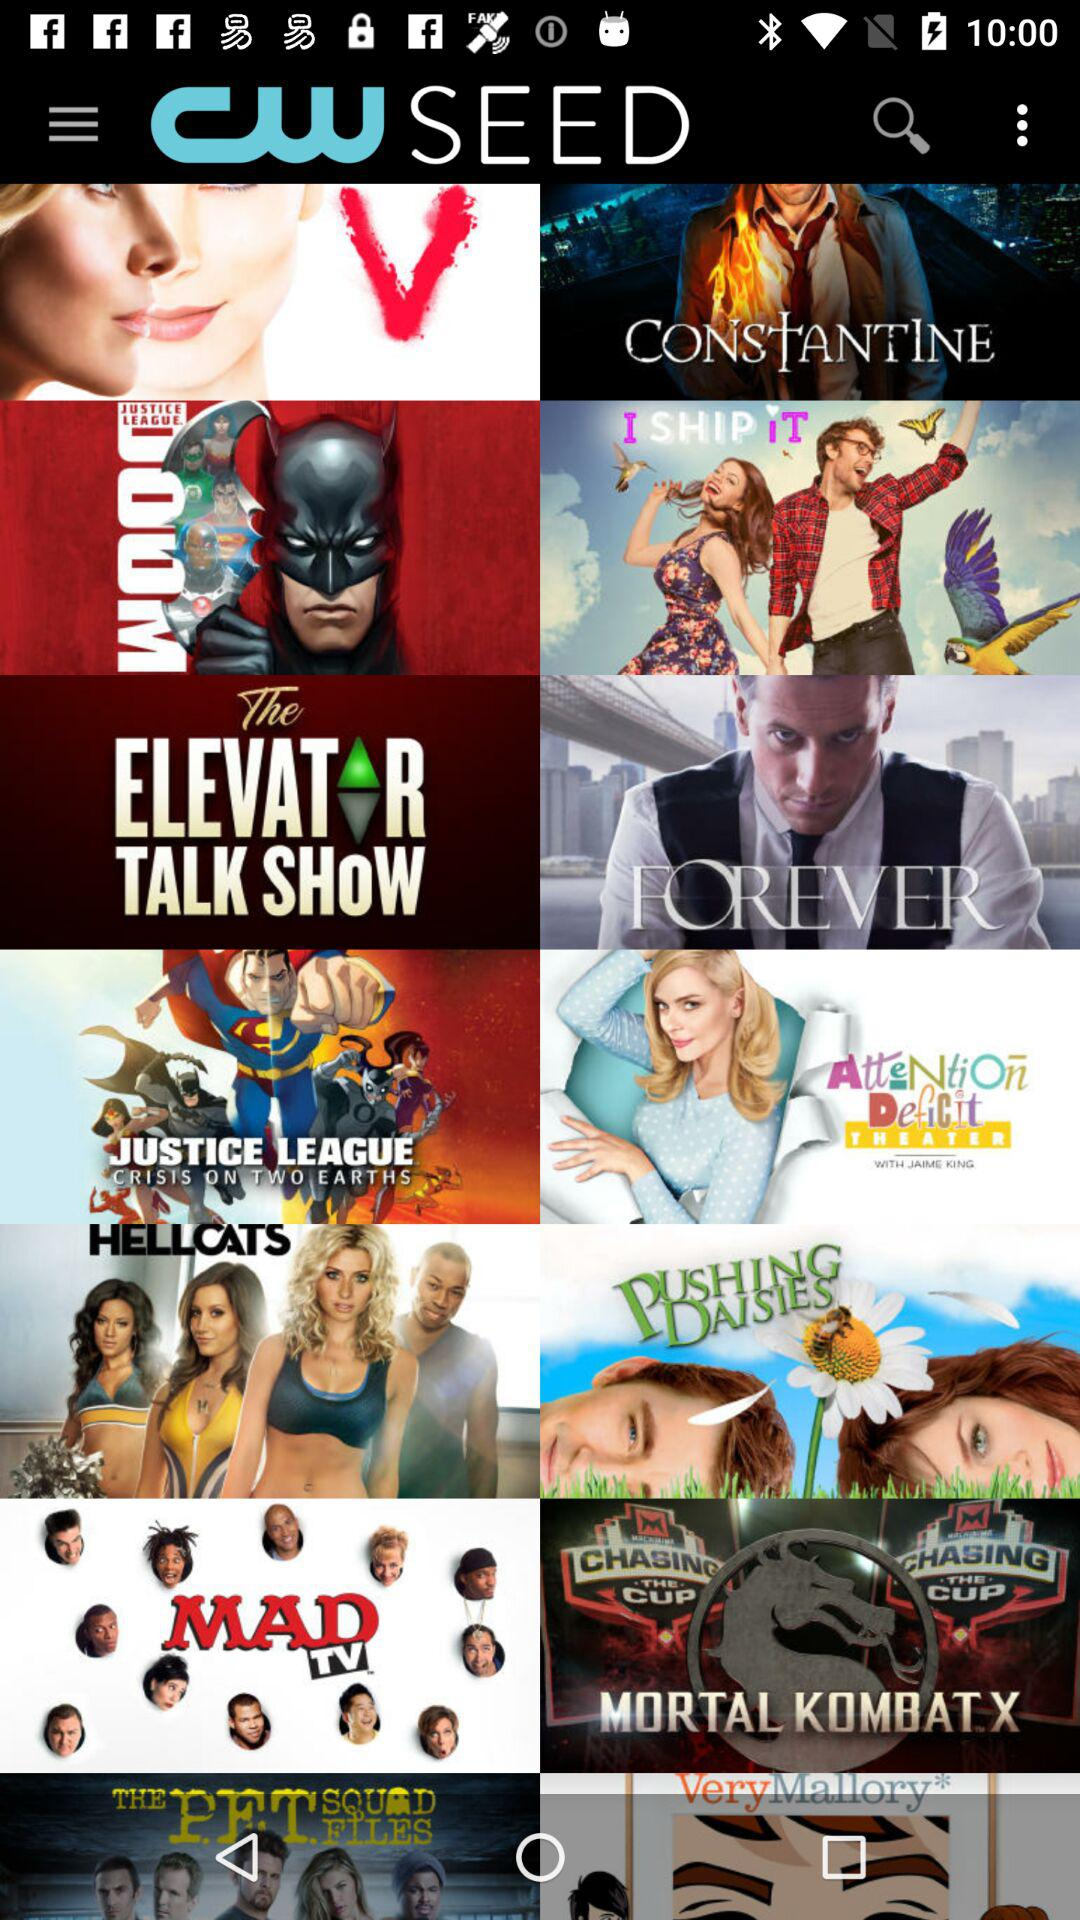What is the application name? The application name is "CW SEED". 